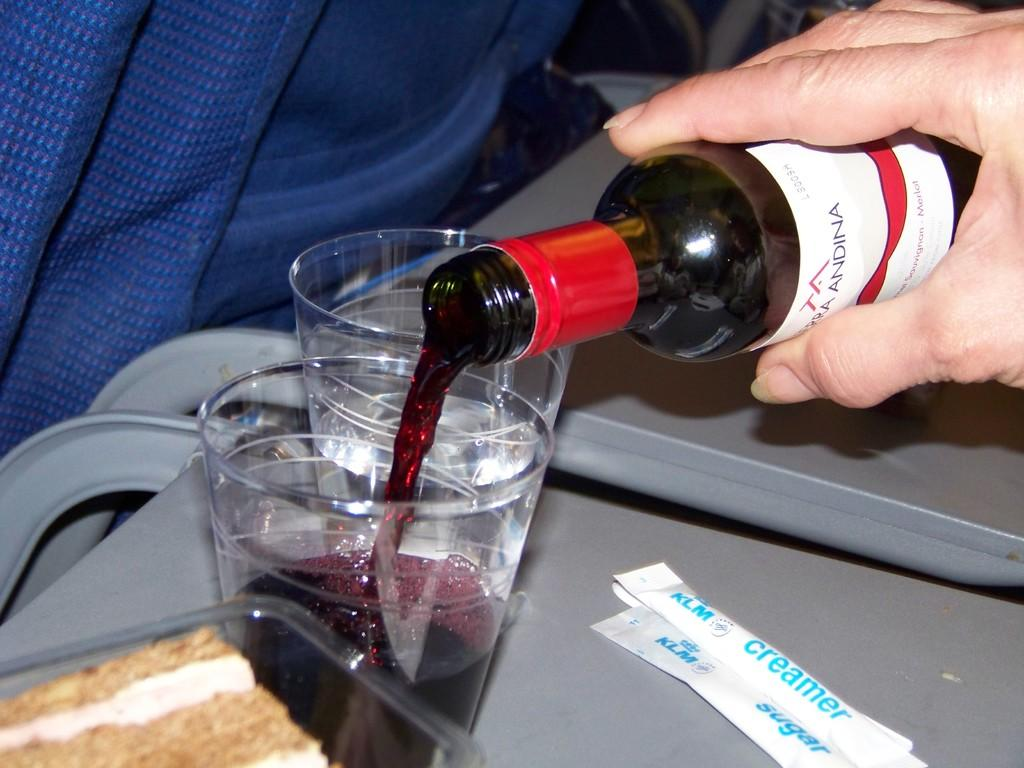<image>
Offer a succinct explanation of the picture presented. A miniature wine bottle has Andina visible on the label is being poured. 